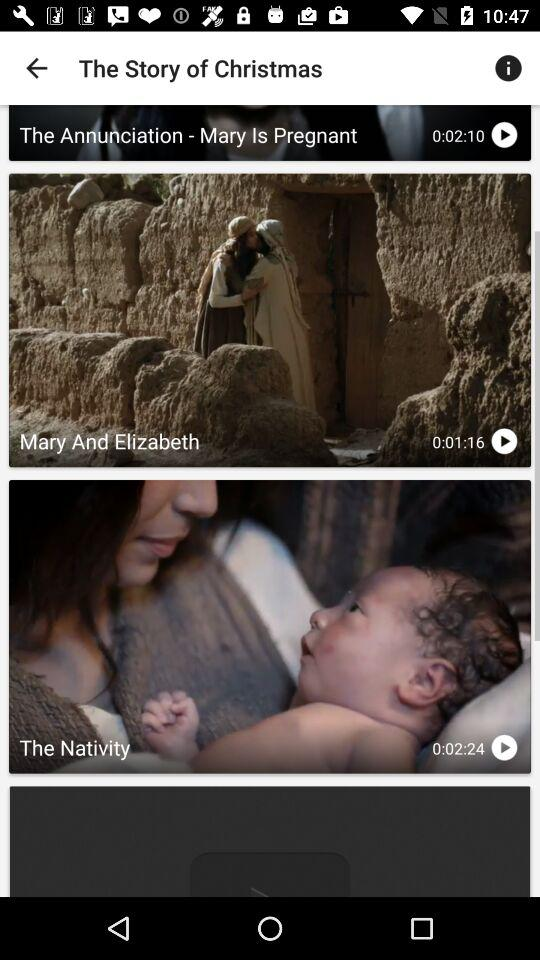What is the name of the application? The name of the application is "YouVersion". 